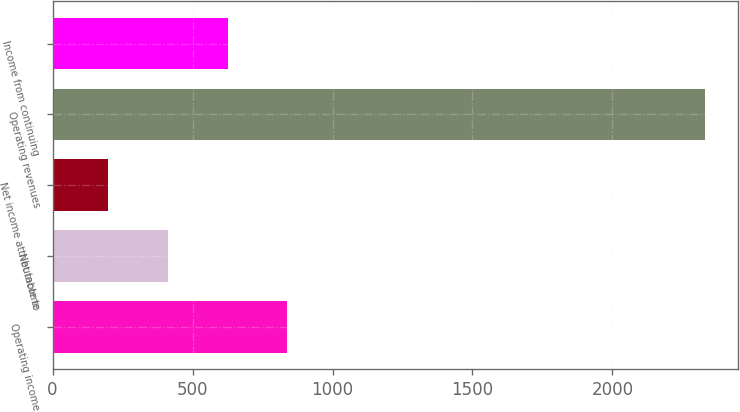Convert chart. <chart><loc_0><loc_0><loc_500><loc_500><bar_chart><fcel>Operating income<fcel>Net income<fcel>Net income attributable to<fcel>Operating revenues<fcel>Income from continuing<nl><fcel>838.9<fcel>412.3<fcel>199<fcel>2332<fcel>625.6<nl></chart> 